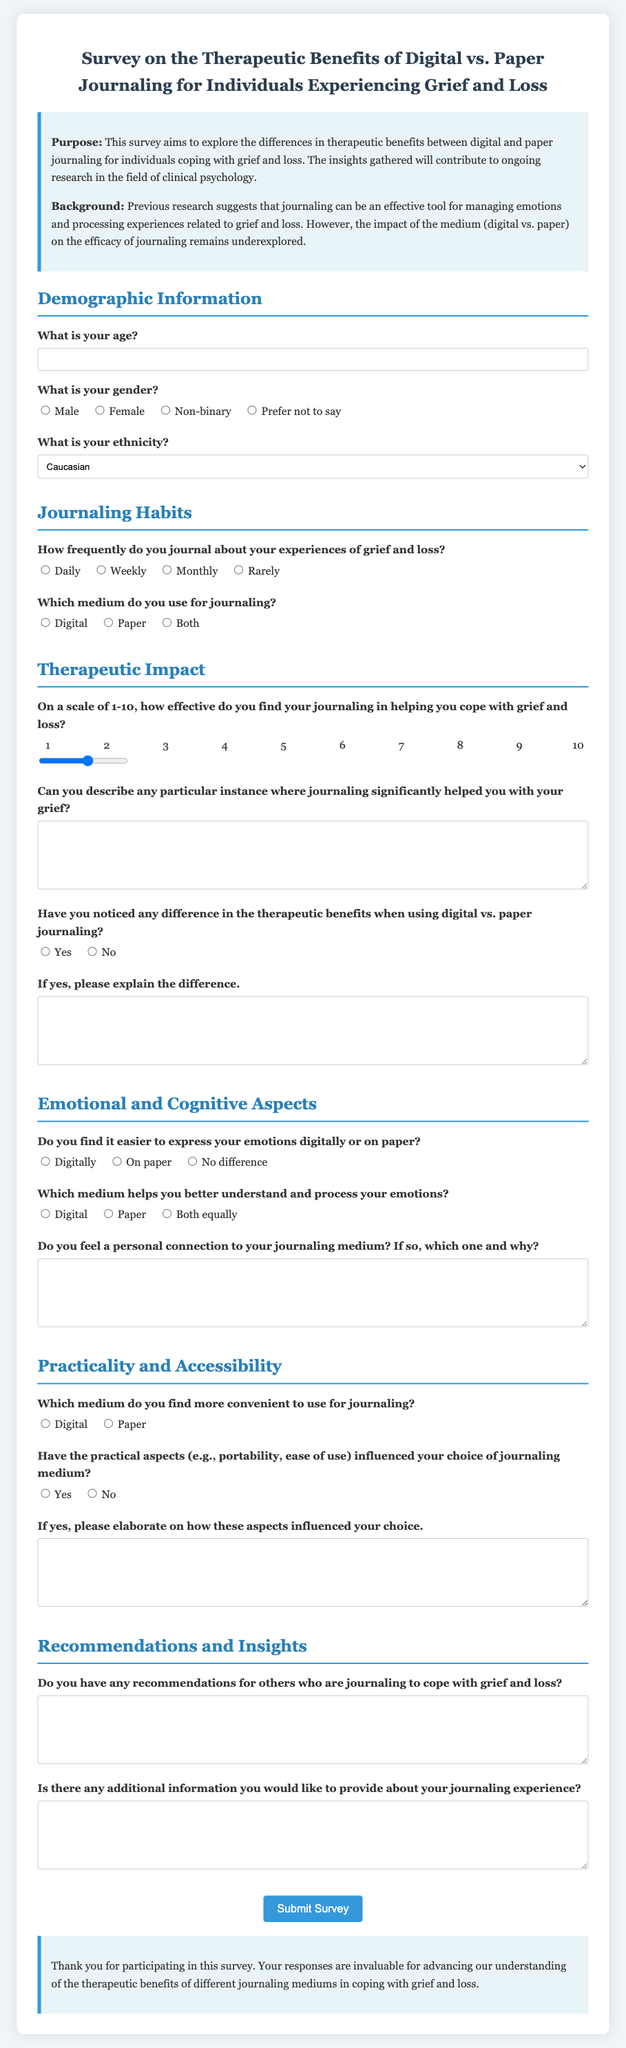What is the title of the survey? The title of the survey is provided at the beginning of the document.
Answer: Survey on the Therapeutic Benefits of Digital vs. Paper Journaling for Individuals Experiencing Grief and Loss What is the purpose of the survey? The purpose is stated in the introduction section of the document.
Answer: To explore the differences in therapeutic benefits between digital and paper journaling for individuals coping with grief and loss How many sections are there in the survey? The number of sections is indicated by the main headers throughout the document.
Answer: Five What scale is used to rate the effectiveness of journaling? The scale mentioned in the therapeutic impact section.
Answer: 1-10 What type of journaling medium is included in the options? The options mentioned for the journaling medium in the survey are specified.
Answer: Digital, Paper, Both Which question asks about the convenience of using a journaling medium? The question is found in the practicality and accessibility section regarding convenience.
Answer: Which medium do you find more convenient to use for journaling? What is one of the demographic questions in the survey? Demographic questions are listed in the first section, and this addresses age.
Answer: What is your age? How are participants requested to describe significant journaling instances? This is specified in a question that asks for personal experiences related to journaling.
Answer: Can you describe any particular instance where journaling significantly helped you with your grief? 